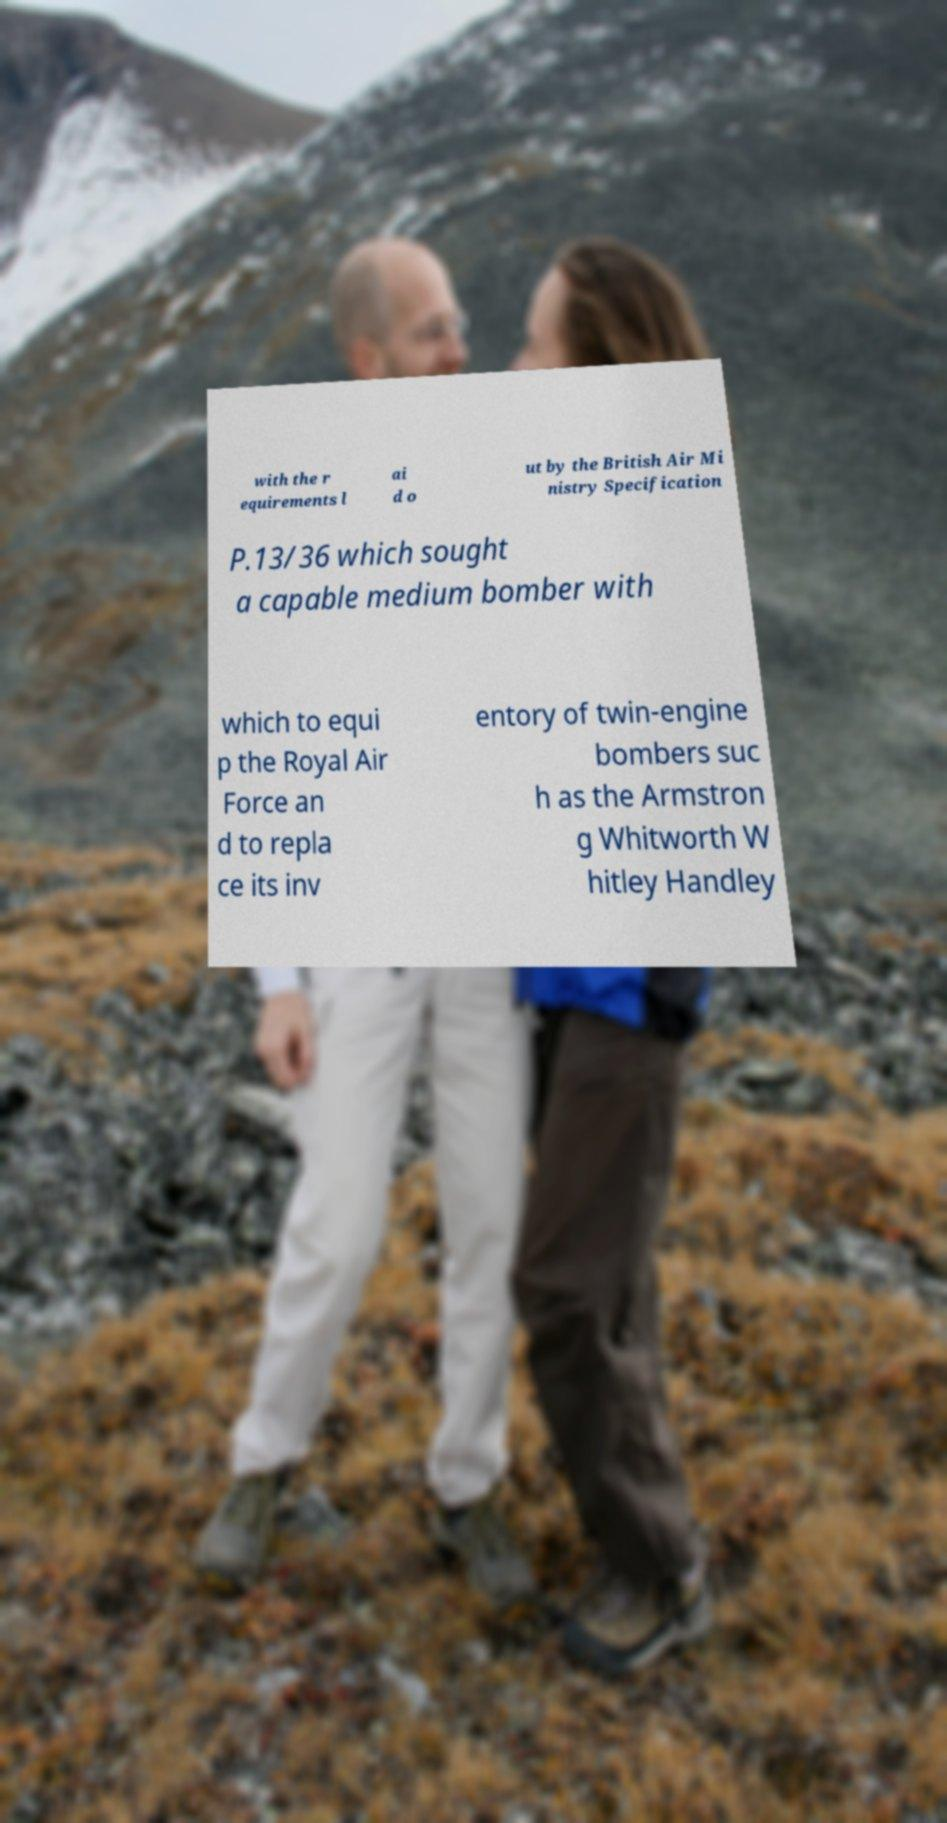Can you accurately transcribe the text from the provided image for me? with the r equirements l ai d o ut by the British Air Mi nistry Specification P.13/36 which sought a capable medium bomber with which to equi p the Royal Air Force an d to repla ce its inv entory of twin-engine bombers suc h as the Armstron g Whitworth W hitley Handley 